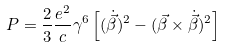Convert formula to latex. <formula><loc_0><loc_0><loc_500><loc_500>P = \frac { 2 } { 3 } \frac { e ^ { 2 } } { c } \gamma ^ { 6 } \left [ ( \dot { \vec { \beta } } ) ^ { 2 } - ( \vec { \beta } \times \dot { \vec { \beta } } ) ^ { 2 } \right ]</formula> 